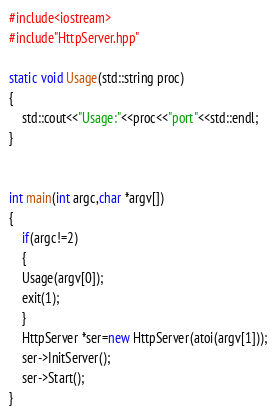<code> <loc_0><loc_0><loc_500><loc_500><_C++_>#include<iostream>
#include"HttpServer.hpp"

static void Usage(std::string proc)
{
    std::cout<<"Usage:"<<proc<<"port"<<std::endl;
}


int main(int argc,char *argv[])	
{
    if(argc!=2)
    {
	Usage(argv[0]);
	exit(1);
    }
    HttpServer *ser=new HttpServer(atoi(argv[1]));
    ser->InitServer();
    ser->Start();
}
</code> 